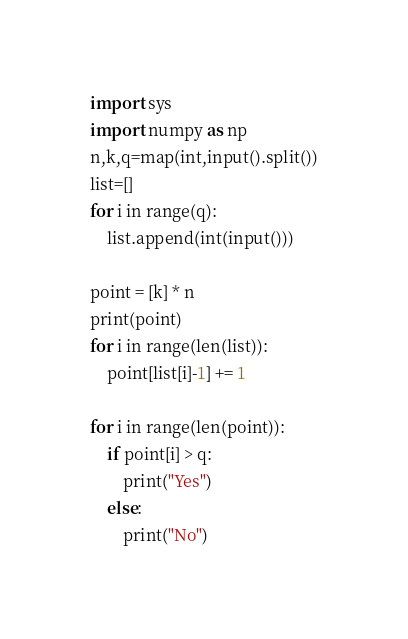<code> <loc_0><loc_0><loc_500><loc_500><_Python_>import sys
import numpy as np
n,k,q=map(int,input().split())
list=[]
for i in range(q):
    list.append(int(input()))

point = [k] * n
print(point)
for i in range(len(list)):
    point[list[i]-1] += 1

for i in range(len(point)):
    if point[i] > q:
        print("Yes")
    else:
        print("No")</code> 